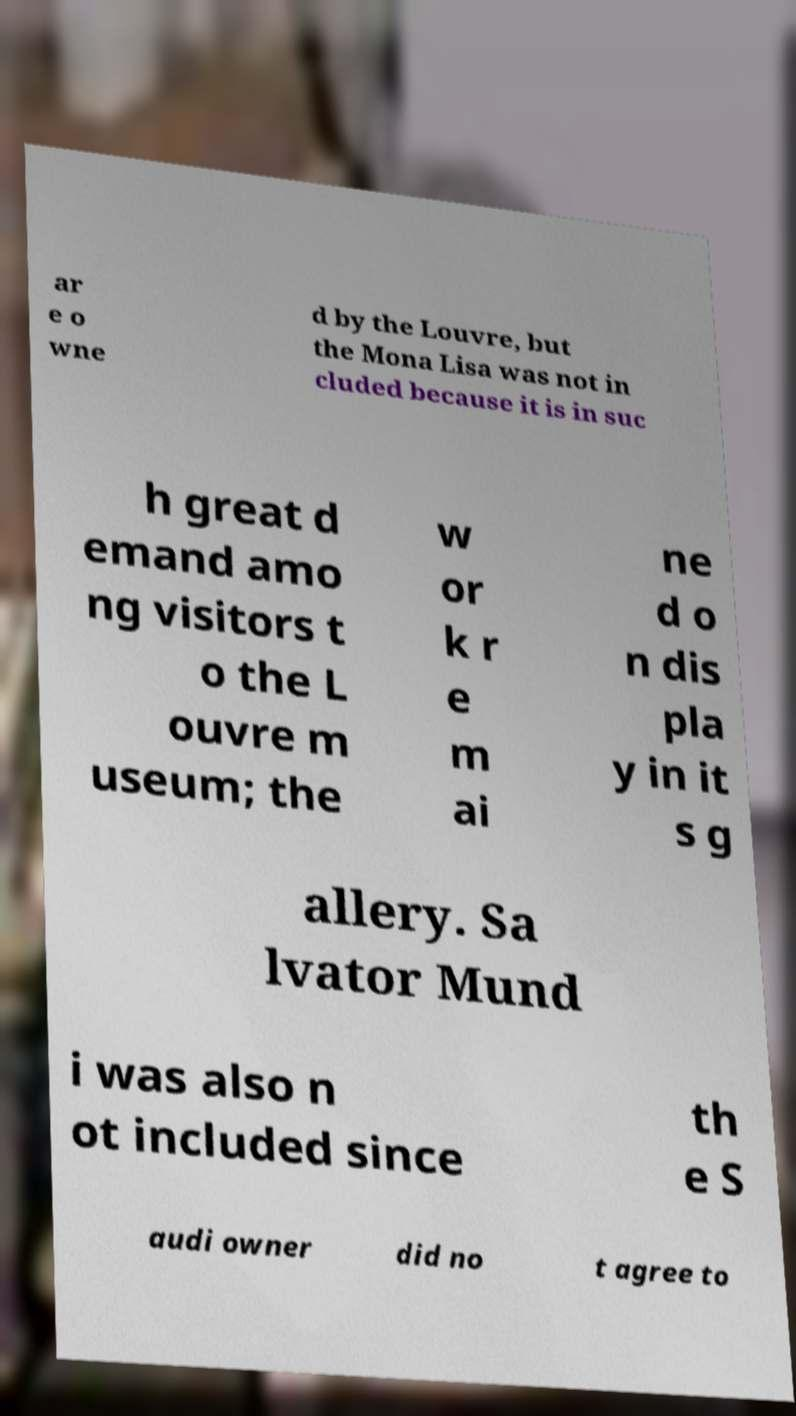Could you assist in decoding the text presented in this image and type it out clearly? ar e o wne d by the Louvre, but the Mona Lisa was not in cluded because it is in suc h great d emand amo ng visitors t o the L ouvre m useum; the w or k r e m ai ne d o n dis pla y in it s g allery. Sa lvator Mund i was also n ot included since th e S audi owner did no t agree to 